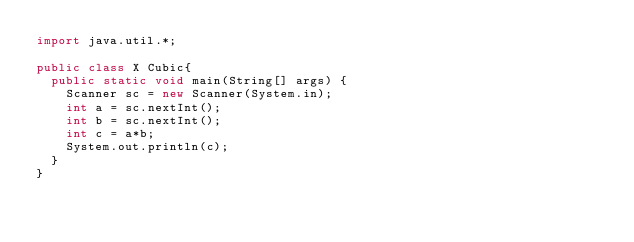Convert code to text. <code><loc_0><loc_0><loc_500><loc_500><_Java_>import java.util.*;

public class X Cubic{
  public static void main(String[] args) {
    Scanner sc = new Scanner(System.in);
    int a = sc.nextInt();
    int b = sc.nextInt();
    int c = a*b;
    System.out.println(c);
  }
}</code> 